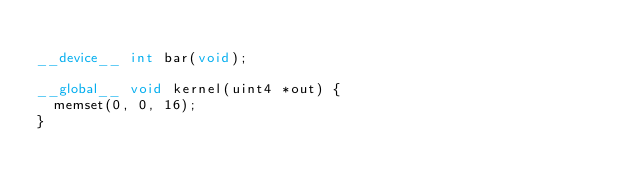Convert code to text. <code><loc_0><loc_0><loc_500><loc_500><_Cuda_>
__device__ int bar(void);

__global__ void kernel(uint4 *out) {
  memset(0, 0, 16);
}
</code> 